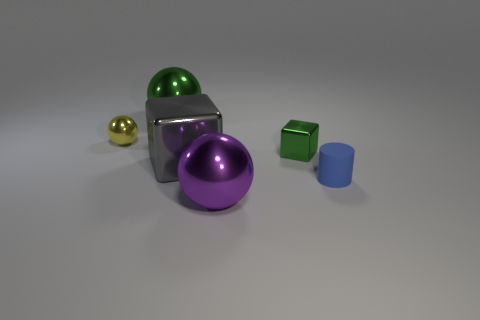Subtract 1 spheres. How many spheres are left? 2 Add 1 purple metal things. How many objects exist? 7 Subtract all cylinders. How many objects are left? 5 Add 3 large gray cubes. How many large gray cubes are left? 4 Add 3 small gray rubber cylinders. How many small gray rubber cylinders exist? 3 Subtract 1 green spheres. How many objects are left? 5 Subtract all shiny cubes. Subtract all matte cylinders. How many objects are left? 3 